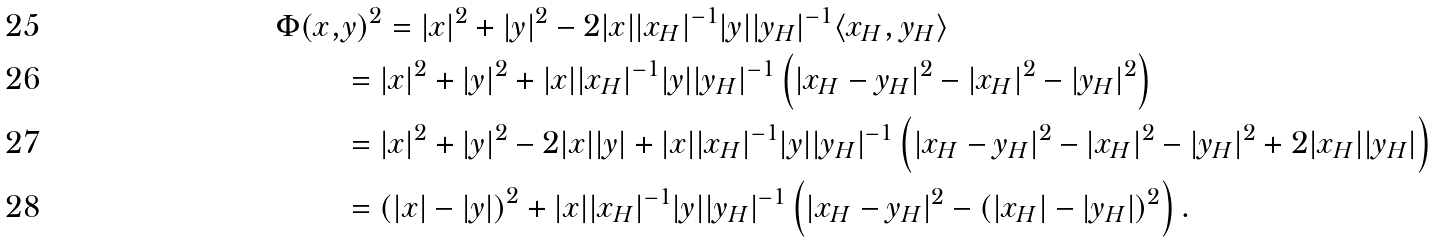<formula> <loc_0><loc_0><loc_500><loc_500>\Phi ( x , & y ) ^ { 2 } = | x | ^ { 2 } + | y | ^ { 2 } - 2 | x | | x _ { H } | ^ { - 1 } | y | | y _ { H } | ^ { - 1 } \langle x _ { H } , y _ { H } \rangle \\ & = | x | ^ { 2 } + | y | ^ { 2 } + | x | | x _ { H } | ^ { - 1 } | y | | y _ { H } | ^ { - 1 } \left ( | x _ { H } - y _ { H } | ^ { 2 } - | x _ { H } | ^ { 2 } - | y _ { H } | ^ { 2 } \right ) \\ & = | x | ^ { 2 } + | y | ^ { 2 } - 2 | x | | y | + | x | | x _ { H } | ^ { - 1 } | y | | y _ { H } | ^ { - 1 } \left ( | x _ { H } - y _ { H } | ^ { 2 } - | x _ { H } | ^ { 2 } - | y _ { H } | ^ { 2 } + 2 | x _ { H } | | y _ { H } | \right ) \\ & = \left ( | x | - | y | \right ) ^ { 2 } + | x | | x _ { H } | ^ { - 1 } | y | | y _ { H } | ^ { - 1 } \left ( | x _ { H } - y _ { H } | ^ { 2 } - ( | x _ { H } | - | y _ { H } | ) ^ { 2 } \right ) .</formula> 